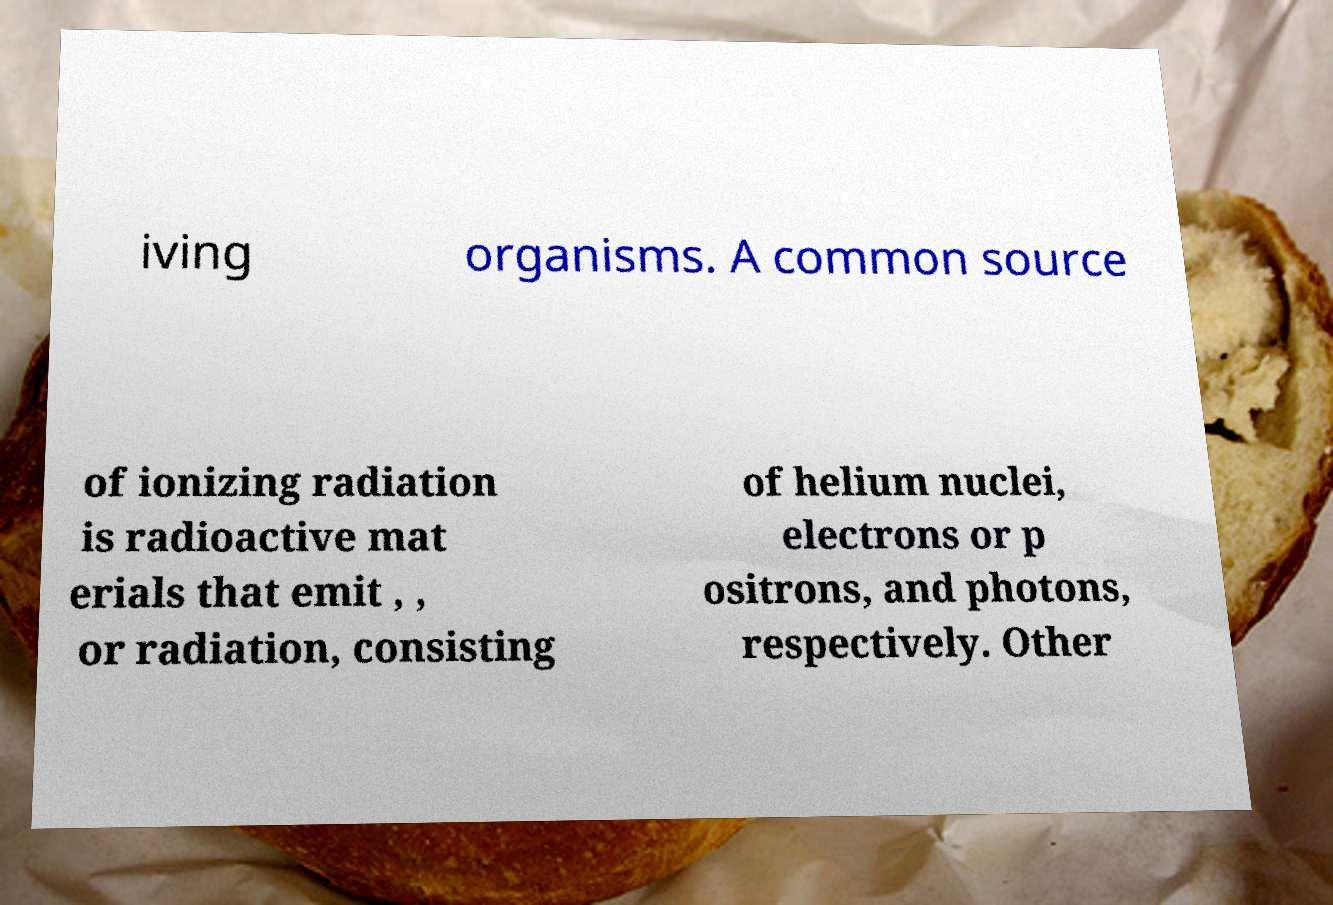Could you extract and type out the text from this image? iving organisms. A common source of ionizing radiation is radioactive mat erials that emit , , or radiation, consisting of helium nuclei, electrons or p ositrons, and photons, respectively. Other 